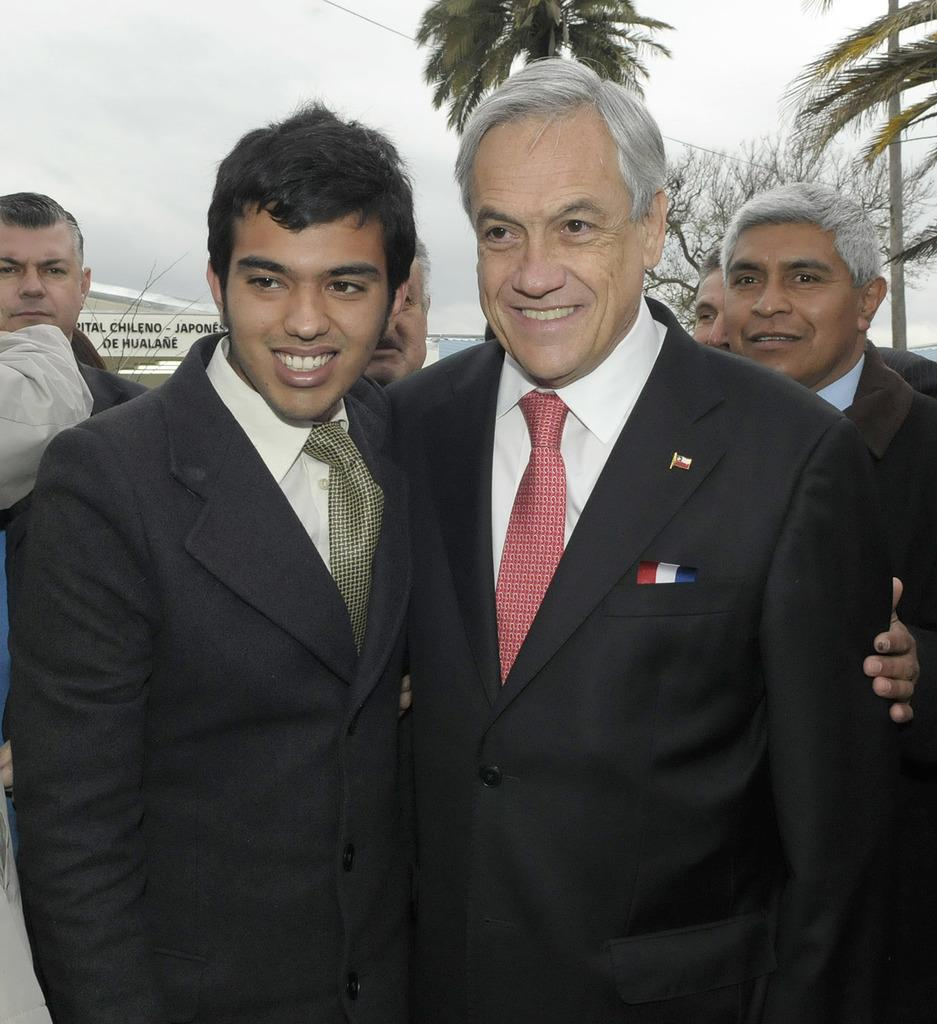How many people are present in the image? There are two people standing in the image. What is the facial expression of the people in the image? The two people are smiling. What can be seen in the background of the image? There are people, a board, a wire, and trees visible in the background of the image. Where is the girl using the calculator in the image? There is no girl or calculator present in the image. 